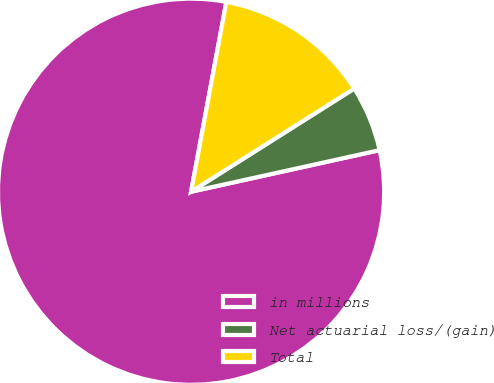<chart> <loc_0><loc_0><loc_500><loc_500><pie_chart><fcel>in millions<fcel>Net actuarial loss/(gain)<fcel>Total<nl><fcel>81.38%<fcel>5.52%<fcel>13.1%<nl></chart> 